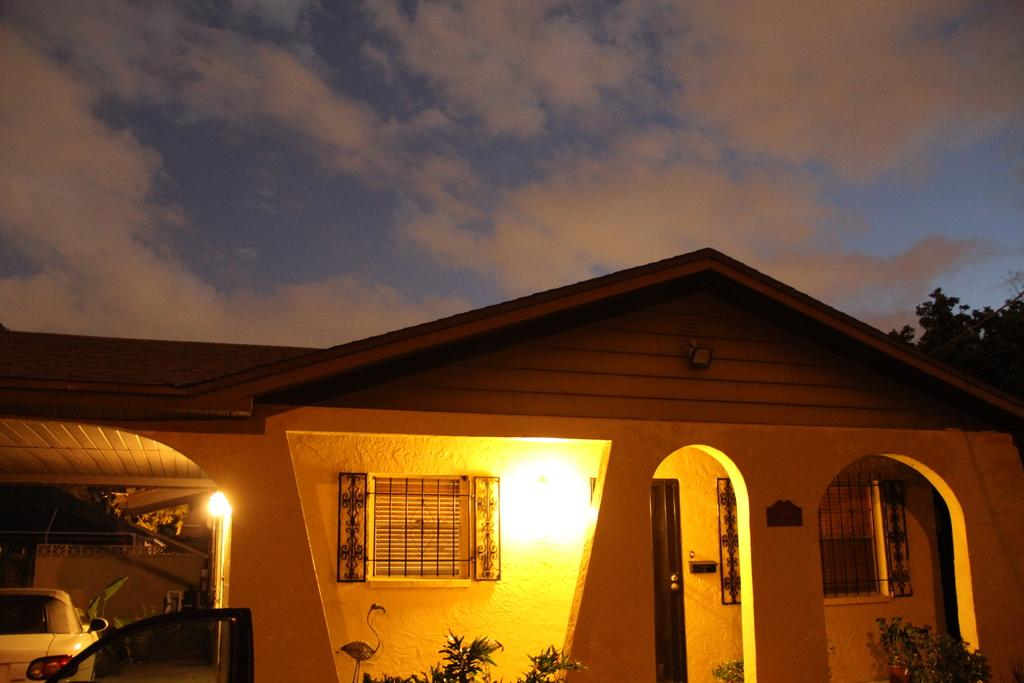What is the main structure in the center of the image? There is a house in the center of the image. What type of vehicle can be seen in the image? There is a car in the image. What is visible at the top of the image? The sky is visible at the top of the image. What can be observed in the sky? Clouds are present in the sky. What type of vegetation is in the image? There are trees in the image. What type of joke is being told by the trees in the image? There are no jokes being told in the image, and the trees do not have the ability to communicate or tell jokes. 